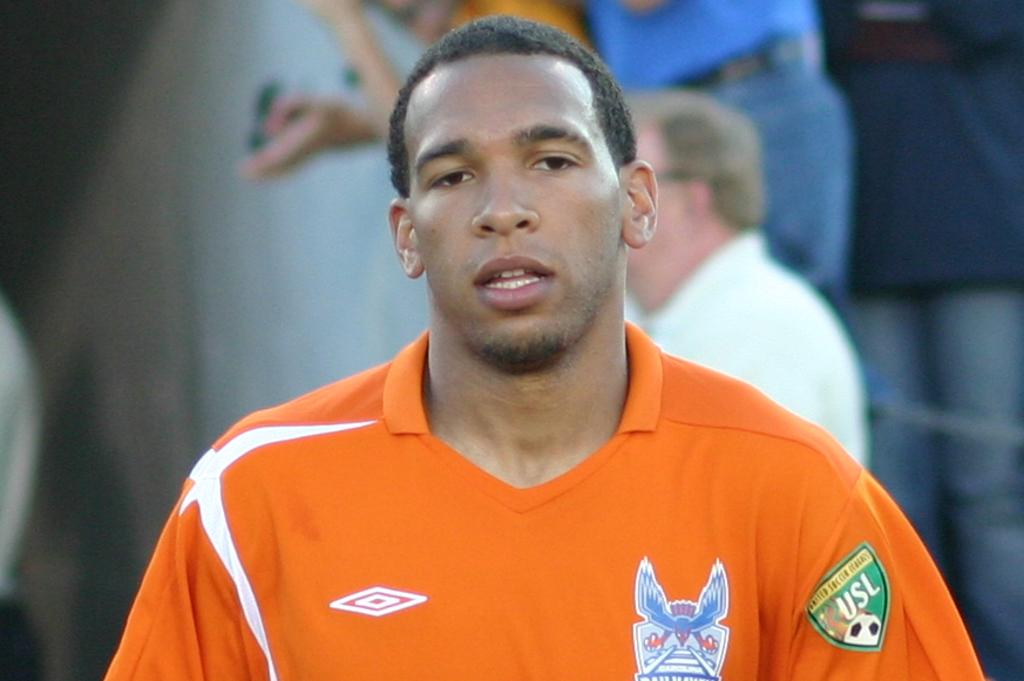<image>
Give a short and clear explanation of the subsequent image. A soccer player in an orange jersey has the USL patch on his left arm near the shoulder. 